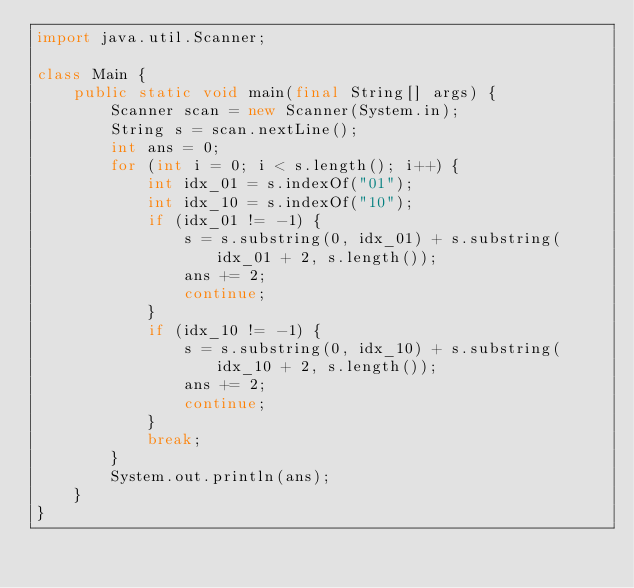<code> <loc_0><loc_0><loc_500><loc_500><_Java_>import java.util.Scanner;

class Main {
    public static void main(final String[] args) {
        Scanner scan = new Scanner(System.in);
        String s = scan.nextLine();
        int ans = 0;
        for (int i = 0; i < s.length(); i++) {
            int idx_01 = s.indexOf("01");
            int idx_10 = s.indexOf("10");
            if (idx_01 != -1) {
                s = s.substring(0, idx_01) + s.substring(idx_01 + 2, s.length());
                ans += 2;
                continue;
            }
            if (idx_10 != -1) {
                s = s.substring(0, idx_10) + s.substring(idx_10 + 2, s.length());
                ans += 2;
                continue;
            }
            break;
        }
        System.out.println(ans);
    }
}</code> 